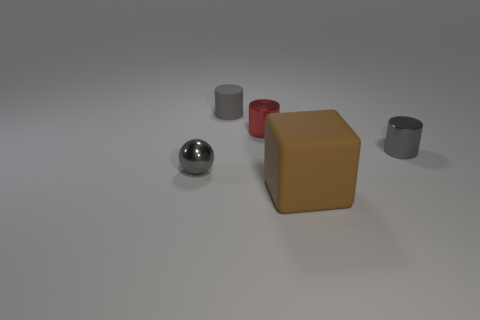What number of brown objects are the same size as the matte cube?
Your answer should be very brief. 0. What is the shape of the matte object that is the same color as the small metallic sphere?
Provide a short and direct response. Cylinder. Is there a gray rubber cylinder?
Provide a succinct answer. Yes. There is a tiny gray thing behind the red cylinder; does it have the same shape as the shiny thing on the right side of the big brown rubber thing?
Keep it short and to the point. Yes. How many big things are either red metal objects or yellow spheres?
Offer a very short reply. 0. Does the tiny red metal thing have the same shape as the gray matte thing?
Provide a short and direct response. Yes. The small matte thing is what color?
Offer a very short reply. Gray. How many things are large gray matte things or large things?
Provide a short and direct response. 1. Are there fewer gray spheres behind the gray rubber cylinder than blue rubber cylinders?
Your answer should be very brief. No. Are there more metallic cylinders to the right of the matte cube than large brown blocks behind the gray rubber object?
Make the answer very short. Yes. 